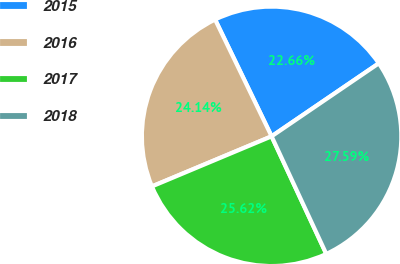Convert chart. <chart><loc_0><loc_0><loc_500><loc_500><pie_chart><fcel>2015<fcel>2016<fcel>2017<fcel>2018<nl><fcel>22.66%<fcel>24.14%<fcel>25.62%<fcel>27.59%<nl></chart> 